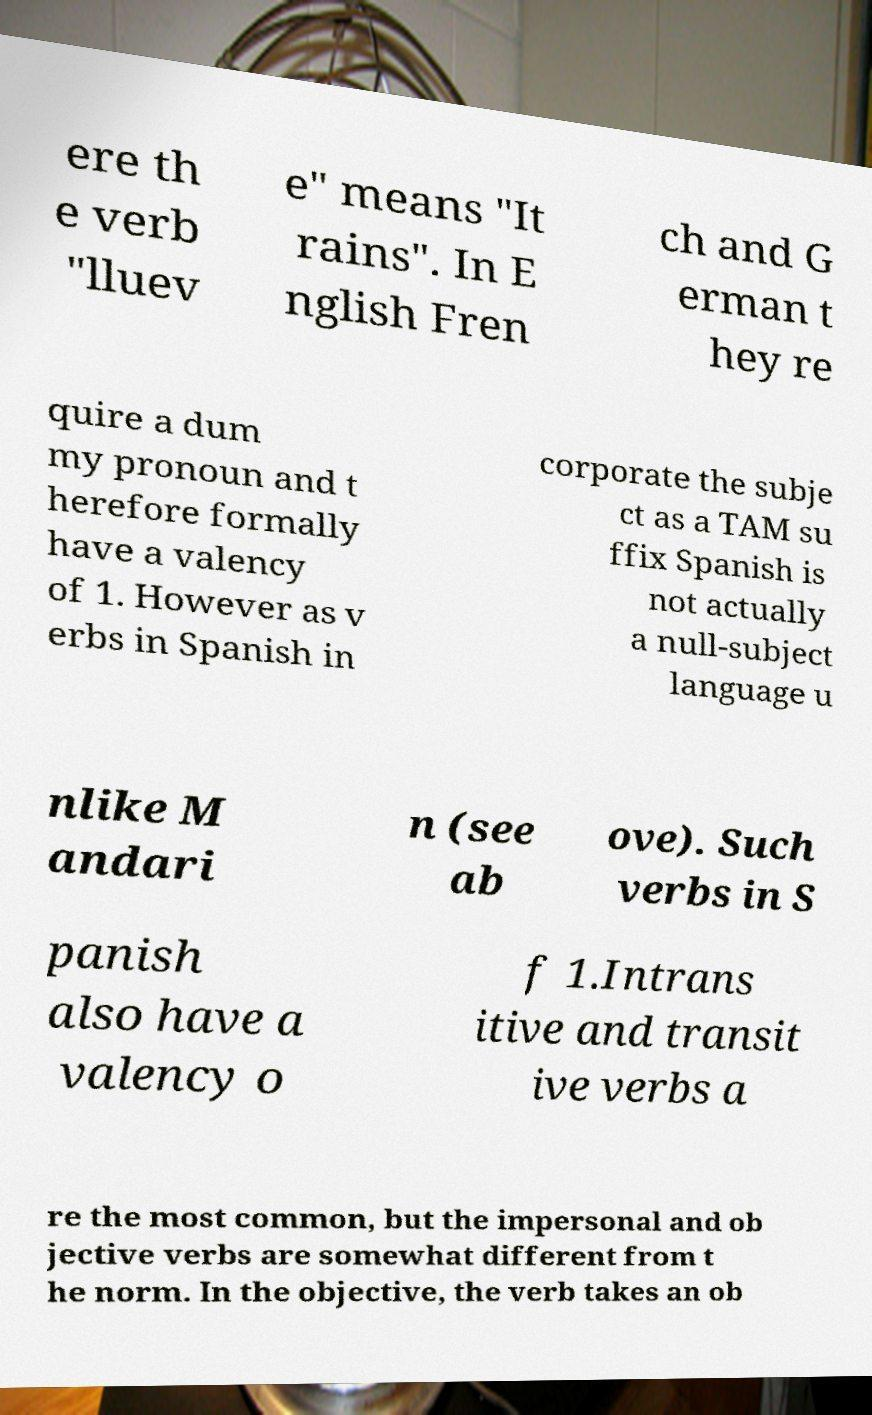Could you assist in decoding the text presented in this image and type it out clearly? ere th e verb "lluev e" means "It rains". In E nglish Fren ch and G erman t hey re quire a dum my pronoun and t herefore formally have a valency of 1. However as v erbs in Spanish in corporate the subje ct as a TAM su ffix Spanish is not actually a null-subject language u nlike M andari n (see ab ove). Such verbs in S panish also have a valency o f 1.Intrans itive and transit ive verbs a re the most common, but the impersonal and ob jective verbs are somewhat different from t he norm. In the objective, the verb takes an ob 